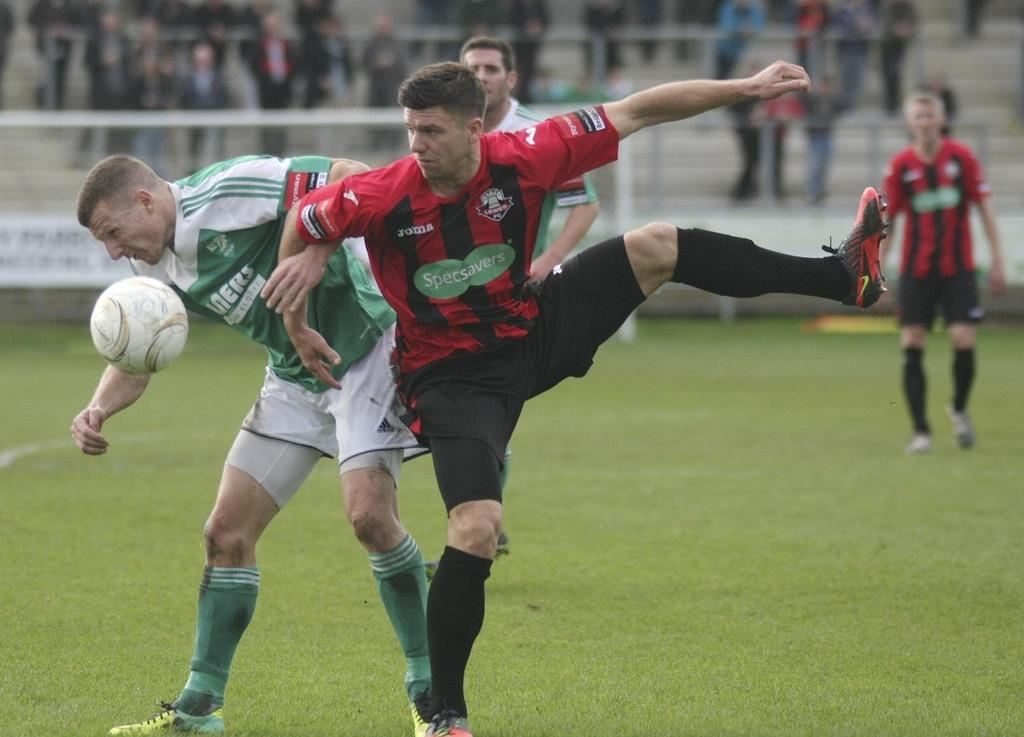What is the setting of the image? The setting of the image is a playground. What are the people in the playground wearing? The people in the playground are wearing jerseys. Are there any other people in the image besides those in the playground? Yes, there are people in the background watching the others. What type of butter can be seen melting on the cart in the image? There is no butter or cart present in the image; it features people in a playground. 